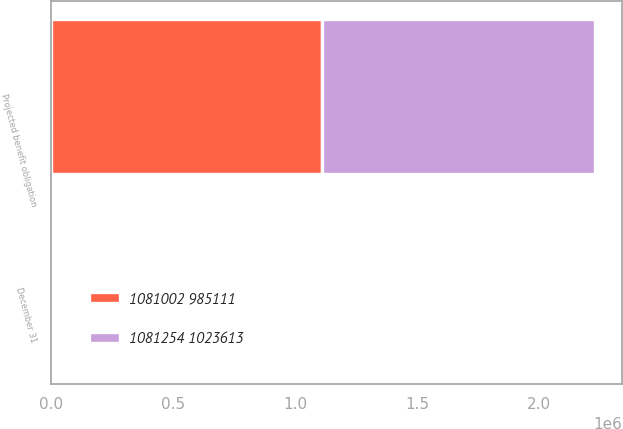Convert chart. <chart><loc_0><loc_0><loc_500><loc_500><stacked_bar_chart><ecel><fcel>December 31<fcel>Projected benefit obligation<nl><fcel>1081254 1023613<fcel>2016<fcel>1.11829e+06<nl><fcel>1081002 985111<fcel>2015<fcel>1.11023e+06<nl></chart> 